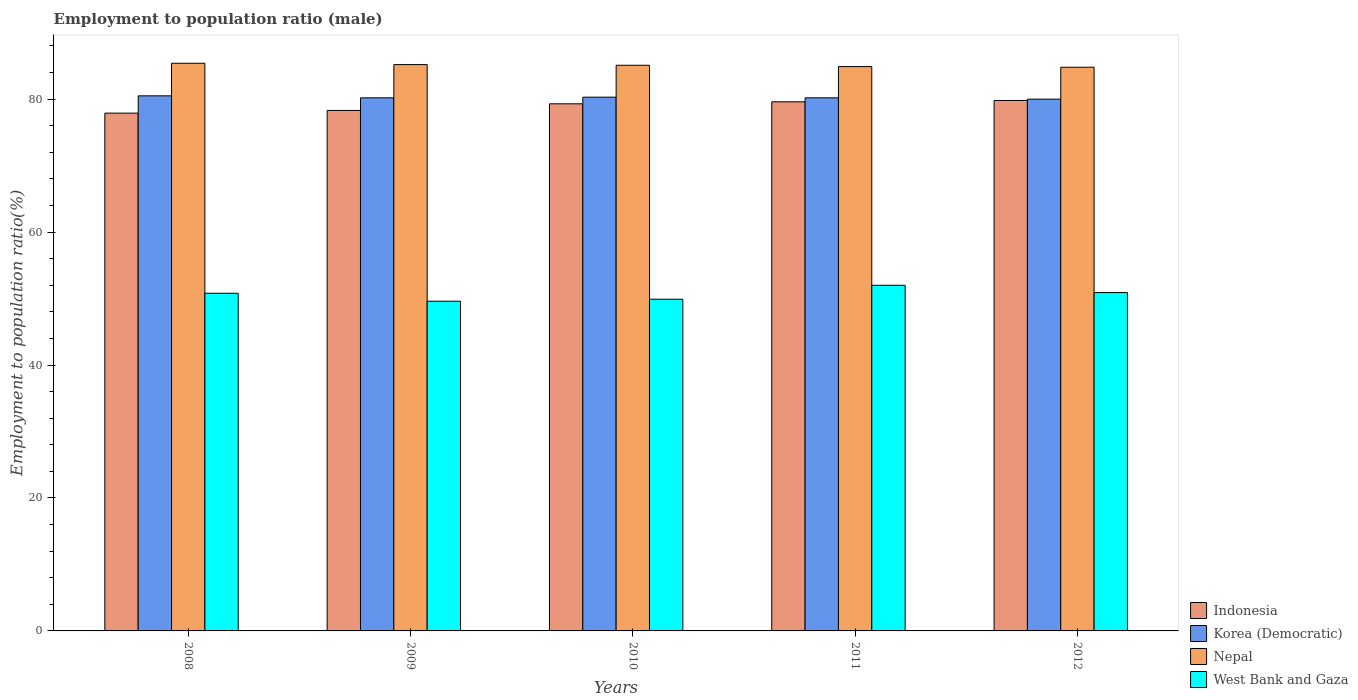How many different coloured bars are there?
Your response must be concise. 4. How many groups of bars are there?
Keep it short and to the point. 5. Are the number of bars per tick equal to the number of legend labels?
Your answer should be very brief. Yes. What is the employment to population ratio in West Bank and Gaza in 2011?
Your answer should be compact. 52. Across all years, what is the maximum employment to population ratio in Korea (Democratic)?
Offer a terse response. 80.5. Across all years, what is the minimum employment to population ratio in Nepal?
Offer a very short reply. 84.8. What is the total employment to population ratio in Korea (Democratic) in the graph?
Offer a terse response. 401.2. What is the difference between the employment to population ratio in Korea (Democratic) in 2009 and that in 2012?
Provide a succinct answer. 0.2. What is the difference between the employment to population ratio in Nepal in 2009 and the employment to population ratio in West Bank and Gaza in 2012?
Provide a short and direct response. 34.3. What is the average employment to population ratio in Korea (Democratic) per year?
Ensure brevity in your answer.  80.24. In the year 2012, what is the difference between the employment to population ratio in Indonesia and employment to population ratio in Korea (Democratic)?
Ensure brevity in your answer.  -0.2. In how many years, is the employment to population ratio in Indonesia greater than 60 %?
Give a very brief answer. 5. What is the ratio of the employment to population ratio in Nepal in 2008 to that in 2010?
Keep it short and to the point. 1. Is the employment to population ratio in Nepal in 2009 less than that in 2011?
Your answer should be compact. No. What is the difference between the highest and the second highest employment to population ratio in Nepal?
Offer a very short reply. 0.2. What is the difference between the highest and the lowest employment to population ratio in Indonesia?
Your response must be concise. 1.9. What does the 2nd bar from the left in 2008 represents?
Ensure brevity in your answer.  Korea (Democratic). What does the 4th bar from the right in 2011 represents?
Make the answer very short. Indonesia. Is it the case that in every year, the sum of the employment to population ratio in Nepal and employment to population ratio in Korea (Democratic) is greater than the employment to population ratio in West Bank and Gaza?
Keep it short and to the point. Yes. What is the difference between two consecutive major ticks on the Y-axis?
Your response must be concise. 20. Does the graph contain any zero values?
Ensure brevity in your answer.  No. Does the graph contain grids?
Your response must be concise. No. Where does the legend appear in the graph?
Ensure brevity in your answer.  Bottom right. How are the legend labels stacked?
Your response must be concise. Vertical. What is the title of the graph?
Your answer should be very brief. Employment to population ratio (male). What is the label or title of the X-axis?
Give a very brief answer. Years. What is the label or title of the Y-axis?
Keep it short and to the point. Employment to population ratio(%). What is the Employment to population ratio(%) of Indonesia in 2008?
Ensure brevity in your answer.  77.9. What is the Employment to population ratio(%) of Korea (Democratic) in 2008?
Offer a terse response. 80.5. What is the Employment to population ratio(%) in Nepal in 2008?
Offer a terse response. 85.4. What is the Employment to population ratio(%) of West Bank and Gaza in 2008?
Provide a short and direct response. 50.8. What is the Employment to population ratio(%) of Indonesia in 2009?
Keep it short and to the point. 78.3. What is the Employment to population ratio(%) of Korea (Democratic) in 2009?
Provide a short and direct response. 80.2. What is the Employment to population ratio(%) in Nepal in 2009?
Make the answer very short. 85.2. What is the Employment to population ratio(%) in West Bank and Gaza in 2009?
Your response must be concise. 49.6. What is the Employment to population ratio(%) of Indonesia in 2010?
Your response must be concise. 79.3. What is the Employment to population ratio(%) of Korea (Democratic) in 2010?
Give a very brief answer. 80.3. What is the Employment to population ratio(%) of Nepal in 2010?
Make the answer very short. 85.1. What is the Employment to population ratio(%) of West Bank and Gaza in 2010?
Your response must be concise. 49.9. What is the Employment to population ratio(%) in Indonesia in 2011?
Make the answer very short. 79.6. What is the Employment to population ratio(%) of Korea (Democratic) in 2011?
Offer a terse response. 80.2. What is the Employment to population ratio(%) of Nepal in 2011?
Provide a short and direct response. 84.9. What is the Employment to population ratio(%) in West Bank and Gaza in 2011?
Make the answer very short. 52. What is the Employment to population ratio(%) of Indonesia in 2012?
Ensure brevity in your answer.  79.8. What is the Employment to population ratio(%) in Korea (Democratic) in 2012?
Provide a short and direct response. 80. What is the Employment to population ratio(%) in Nepal in 2012?
Offer a very short reply. 84.8. What is the Employment to population ratio(%) in West Bank and Gaza in 2012?
Ensure brevity in your answer.  50.9. Across all years, what is the maximum Employment to population ratio(%) in Indonesia?
Provide a short and direct response. 79.8. Across all years, what is the maximum Employment to population ratio(%) of Korea (Democratic)?
Ensure brevity in your answer.  80.5. Across all years, what is the maximum Employment to population ratio(%) in Nepal?
Provide a short and direct response. 85.4. Across all years, what is the maximum Employment to population ratio(%) of West Bank and Gaza?
Your response must be concise. 52. Across all years, what is the minimum Employment to population ratio(%) in Indonesia?
Your answer should be compact. 77.9. Across all years, what is the minimum Employment to population ratio(%) of Korea (Democratic)?
Your answer should be compact. 80. Across all years, what is the minimum Employment to population ratio(%) in Nepal?
Make the answer very short. 84.8. Across all years, what is the minimum Employment to population ratio(%) of West Bank and Gaza?
Keep it short and to the point. 49.6. What is the total Employment to population ratio(%) in Indonesia in the graph?
Provide a succinct answer. 394.9. What is the total Employment to population ratio(%) of Korea (Democratic) in the graph?
Your answer should be compact. 401.2. What is the total Employment to population ratio(%) of Nepal in the graph?
Your answer should be very brief. 425.4. What is the total Employment to population ratio(%) in West Bank and Gaza in the graph?
Ensure brevity in your answer.  253.2. What is the difference between the Employment to population ratio(%) in Indonesia in 2008 and that in 2009?
Make the answer very short. -0.4. What is the difference between the Employment to population ratio(%) of Korea (Democratic) in 2008 and that in 2009?
Your answer should be very brief. 0.3. What is the difference between the Employment to population ratio(%) of West Bank and Gaza in 2008 and that in 2009?
Ensure brevity in your answer.  1.2. What is the difference between the Employment to population ratio(%) of Indonesia in 2008 and that in 2010?
Your response must be concise. -1.4. What is the difference between the Employment to population ratio(%) in Korea (Democratic) in 2008 and that in 2010?
Offer a very short reply. 0.2. What is the difference between the Employment to population ratio(%) in Nepal in 2008 and that in 2010?
Your response must be concise. 0.3. What is the difference between the Employment to population ratio(%) in West Bank and Gaza in 2008 and that in 2010?
Give a very brief answer. 0.9. What is the difference between the Employment to population ratio(%) of Indonesia in 2008 and that in 2011?
Offer a very short reply. -1.7. What is the difference between the Employment to population ratio(%) of West Bank and Gaza in 2008 and that in 2012?
Make the answer very short. -0.1. What is the difference between the Employment to population ratio(%) in Indonesia in 2009 and that in 2010?
Provide a succinct answer. -1. What is the difference between the Employment to population ratio(%) in Korea (Democratic) in 2009 and that in 2010?
Offer a terse response. -0.1. What is the difference between the Employment to population ratio(%) of Nepal in 2009 and that in 2010?
Provide a short and direct response. 0.1. What is the difference between the Employment to population ratio(%) of West Bank and Gaza in 2009 and that in 2010?
Your answer should be compact. -0.3. What is the difference between the Employment to population ratio(%) of Korea (Democratic) in 2009 and that in 2011?
Provide a succinct answer. 0. What is the difference between the Employment to population ratio(%) of Indonesia in 2009 and that in 2012?
Ensure brevity in your answer.  -1.5. What is the difference between the Employment to population ratio(%) in Korea (Democratic) in 2010 and that in 2011?
Your answer should be very brief. 0.1. What is the difference between the Employment to population ratio(%) of Nepal in 2010 and that in 2011?
Ensure brevity in your answer.  0.2. What is the difference between the Employment to population ratio(%) in Indonesia in 2010 and that in 2012?
Your answer should be very brief. -0.5. What is the difference between the Employment to population ratio(%) in Korea (Democratic) in 2010 and that in 2012?
Offer a terse response. 0.3. What is the difference between the Employment to population ratio(%) of Indonesia in 2011 and that in 2012?
Ensure brevity in your answer.  -0.2. What is the difference between the Employment to population ratio(%) of West Bank and Gaza in 2011 and that in 2012?
Make the answer very short. 1.1. What is the difference between the Employment to population ratio(%) in Indonesia in 2008 and the Employment to population ratio(%) in Korea (Democratic) in 2009?
Your response must be concise. -2.3. What is the difference between the Employment to population ratio(%) in Indonesia in 2008 and the Employment to population ratio(%) in West Bank and Gaza in 2009?
Make the answer very short. 28.3. What is the difference between the Employment to population ratio(%) in Korea (Democratic) in 2008 and the Employment to population ratio(%) in Nepal in 2009?
Offer a very short reply. -4.7. What is the difference between the Employment to population ratio(%) of Korea (Democratic) in 2008 and the Employment to population ratio(%) of West Bank and Gaza in 2009?
Your response must be concise. 30.9. What is the difference between the Employment to population ratio(%) of Nepal in 2008 and the Employment to population ratio(%) of West Bank and Gaza in 2009?
Provide a short and direct response. 35.8. What is the difference between the Employment to population ratio(%) of Indonesia in 2008 and the Employment to population ratio(%) of West Bank and Gaza in 2010?
Your answer should be compact. 28. What is the difference between the Employment to population ratio(%) of Korea (Democratic) in 2008 and the Employment to population ratio(%) of West Bank and Gaza in 2010?
Give a very brief answer. 30.6. What is the difference between the Employment to population ratio(%) of Nepal in 2008 and the Employment to population ratio(%) of West Bank and Gaza in 2010?
Give a very brief answer. 35.5. What is the difference between the Employment to population ratio(%) of Indonesia in 2008 and the Employment to population ratio(%) of Korea (Democratic) in 2011?
Ensure brevity in your answer.  -2.3. What is the difference between the Employment to population ratio(%) in Indonesia in 2008 and the Employment to population ratio(%) in West Bank and Gaza in 2011?
Give a very brief answer. 25.9. What is the difference between the Employment to population ratio(%) in Korea (Democratic) in 2008 and the Employment to population ratio(%) in Nepal in 2011?
Provide a short and direct response. -4.4. What is the difference between the Employment to population ratio(%) in Nepal in 2008 and the Employment to population ratio(%) in West Bank and Gaza in 2011?
Your response must be concise. 33.4. What is the difference between the Employment to population ratio(%) in Indonesia in 2008 and the Employment to population ratio(%) in Nepal in 2012?
Provide a short and direct response. -6.9. What is the difference between the Employment to population ratio(%) of Korea (Democratic) in 2008 and the Employment to population ratio(%) of West Bank and Gaza in 2012?
Provide a succinct answer. 29.6. What is the difference between the Employment to population ratio(%) in Nepal in 2008 and the Employment to population ratio(%) in West Bank and Gaza in 2012?
Your answer should be compact. 34.5. What is the difference between the Employment to population ratio(%) of Indonesia in 2009 and the Employment to population ratio(%) of West Bank and Gaza in 2010?
Make the answer very short. 28.4. What is the difference between the Employment to population ratio(%) in Korea (Democratic) in 2009 and the Employment to population ratio(%) in West Bank and Gaza in 2010?
Your answer should be very brief. 30.3. What is the difference between the Employment to population ratio(%) of Nepal in 2009 and the Employment to population ratio(%) of West Bank and Gaza in 2010?
Make the answer very short. 35.3. What is the difference between the Employment to population ratio(%) in Indonesia in 2009 and the Employment to population ratio(%) in Nepal in 2011?
Give a very brief answer. -6.6. What is the difference between the Employment to population ratio(%) of Indonesia in 2009 and the Employment to population ratio(%) of West Bank and Gaza in 2011?
Your response must be concise. 26.3. What is the difference between the Employment to population ratio(%) in Korea (Democratic) in 2009 and the Employment to population ratio(%) in Nepal in 2011?
Keep it short and to the point. -4.7. What is the difference between the Employment to population ratio(%) in Korea (Democratic) in 2009 and the Employment to population ratio(%) in West Bank and Gaza in 2011?
Keep it short and to the point. 28.2. What is the difference between the Employment to population ratio(%) of Nepal in 2009 and the Employment to population ratio(%) of West Bank and Gaza in 2011?
Your response must be concise. 33.2. What is the difference between the Employment to population ratio(%) in Indonesia in 2009 and the Employment to population ratio(%) in Nepal in 2012?
Offer a very short reply. -6.5. What is the difference between the Employment to population ratio(%) of Indonesia in 2009 and the Employment to population ratio(%) of West Bank and Gaza in 2012?
Provide a succinct answer. 27.4. What is the difference between the Employment to population ratio(%) of Korea (Democratic) in 2009 and the Employment to population ratio(%) of West Bank and Gaza in 2012?
Provide a short and direct response. 29.3. What is the difference between the Employment to population ratio(%) of Nepal in 2009 and the Employment to population ratio(%) of West Bank and Gaza in 2012?
Provide a succinct answer. 34.3. What is the difference between the Employment to population ratio(%) of Indonesia in 2010 and the Employment to population ratio(%) of Korea (Democratic) in 2011?
Your answer should be compact. -0.9. What is the difference between the Employment to population ratio(%) in Indonesia in 2010 and the Employment to population ratio(%) in Nepal in 2011?
Make the answer very short. -5.6. What is the difference between the Employment to population ratio(%) in Indonesia in 2010 and the Employment to population ratio(%) in West Bank and Gaza in 2011?
Your response must be concise. 27.3. What is the difference between the Employment to population ratio(%) of Korea (Democratic) in 2010 and the Employment to population ratio(%) of Nepal in 2011?
Offer a very short reply. -4.6. What is the difference between the Employment to population ratio(%) in Korea (Democratic) in 2010 and the Employment to population ratio(%) in West Bank and Gaza in 2011?
Keep it short and to the point. 28.3. What is the difference between the Employment to population ratio(%) in Nepal in 2010 and the Employment to population ratio(%) in West Bank and Gaza in 2011?
Your answer should be very brief. 33.1. What is the difference between the Employment to population ratio(%) in Indonesia in 2010 and the Employment to population ratio(%) in West Bank and Gaza in 2012?
Provide a short and direct response. 28.4. What is the difference between the Employment to population ratio(%) of Korea (Democratic) in 2010 and the Employment to population ratio(%) of Nepal in 2012?
Offer a terse response. -4.5. What is the difference between the Employment to population ratio(%) of Korea (Democratic) in 2010 and the Employment to population ratio(%) of West Bank and Gaza in 2012?
Your answer should be compact. 29.4. What is the difference between the Employment to population ratio(%) of Nepal in 2010 and the Employment to population ratio(%) of West Bank and Gaza in 2012?
Your answer should be very brief. 34.2. What is the difference between the Employment to population ratio(%) of Indonesia in 2011 and the Employment to population ratio(%) of Korea (Democratic) in 2012?
Keep it short and to the point. -0.4. What is the difference between the Employment to population ratio(%) in Indonesia in 2011 and the Employment to population ratio(%) in Nepal in 2012?
Keep it short and to the point. -5.2. What is the difference between the Employment to population ratio(%) in Indonesia in 2011 and the Employment to population ratio(%) in West Bank and Gaza in 2012?
Keep it short and to the point. 28.7. What is the difference between the Employment to population ratio(%) of Korea (Democratic) in 2011 and the Employment to population ratio(%) of West Bank and Gaza in 2012?
Your response must be concise. 29.3. What is the average Employment to population ratio(%) in Indonesia per year?
Ensure brevity in your answer.  78.98. What is the average Employment to population ratio(%) of Korea (Democratic) per year?
Give a very brief answer. 80.24. What is the average Employment to population ratio(%) of Nepal per year?
Offer a terse response. 85.08. What is the average Employment to population ratio(%) in West Bank and Gaza per year?
Offer a very short reply. 50.64. In the year 2008, what is the difference between the Employment to population ratio(%) in Indonesia and Employment to population ratio(%) in Korea (Democratic)?
Provide a succinct answer. -2.6. In the year 2008, what is the difference between the Employment to population ratio(%) of Indonesia and Employment to population ratio(%) of West Bank and Gaza?
Keep it short and to the point. 27.1. In the year 2008, what is the difference between the Employment to population ratio(%) of Korea (Democratic) and Employment to population ratio(%) of West Bank and Gaza?
Keep it short and to the point. 29.7. In the year 2008, what is the difference between the Employment to population ratio(%) in Nepal and Employment to population ratio(%) in West Bank and Gaza?
Keep it short and to the point. 34.6. In the year 2009, what is the difference between the Employment to population ratio(%) of Indonesia and Employment to population ratio(%) of Korea (Democratic)?
Make the answer very short. -1.9. In the year 2009, what is the difference between the Employment to population ratio(%) in Indonesia and Employment to population ratio(%) in Nepal?
Give a very brief answer. -6.9. In the year 2009, what is the difference between the Employment to population ratio(%) of Indonesia and Employment to population ratio(%) of West Bank and Gaza?
Provide a succinct answer. 28.7. In the year 2009, what is the difference between the Employment to population ratio(%) in Korea (Democratic) and Employment to population ratio(%) in Nepal?
Your answer should be compact. -5. In the year 2009, what is the difference between the Employment to population ratio(%) in Korea (Democratic) and Employment to population ratio(%) in West Bank and Gaza?
Provide a short and direct response. 30.6. In the year 2009, what is the difference between the Employment to population ratio(%) in Nepal and Employment to population ratio(%) in West Bank and Gaza?
Provide a short and direct response. 35.6. In the year 2010, what is the difference between the Employment to population ratio(%) in Indonesia and Employment to population ratio(%) in Korea (Democratic)?
Your answer should be very brief. -1. In the year 2010, what is the difference between the Employment to population ratio(%) of Indonesia and Employment to population ratio(%) of Nepal?
Your answer should be compact. -5.8. In the year 2010, what is the difference between the Employment to population ratio(%) of Indonesia and Employment to population ratio(%) of West Bank and Gaza?
Provide a succinct answer. 29.4. In the year 2010, what is the difference between the Employment to population ratio(%) in Korea (Democratic) and Employment to population ratio(%) in West Bank and Gaza?
Your answer should be compact. 30.4. In the year 2010, what is the difference between the Employment to population ratio(%) of Nepal and Employment to population ratio(%) of West Bank and Gaza?
Give a very brief answer. 35.2. In the year 2011, what is the difference between the Employment to population ratio(%) of Indonesia and Employment to population ratio(%) of Nepal?
Your answer should be very brief. -5.3. In the year 2011, what is the difference between the Employment to population ratio(%) of Indonesia and Employment to population ratio(%) of West Bank and Gaza?
Give a very brief answer. 27.6. In the year 2011, what is the difference between the Employment to population ratio(%) in Korea (Democratic) and Employment to population ratio(%) in West Bank and Gaza?
Keep it short and to the point. 28.2. In the year 2011, what is the difference between the Employment to population ratio(%) of Nepal and Employment to population ratio(%) of West Bank and Gaza?
Provide a short and direct response. 32.9. In the year 2012, what is the difference between the Employment to population ratio(%) of Indonesia and Employment to population ratio(%) of West Bank and Gaza?
Offer a very short reply. 28.9. In the year 2012, what is the difference between the Employment to population ratio(%) in Korea (Democratic) and Employment to population ratio(%) in West Bank and Gaza?
Your response must be concise. 29.1. In the year 2012, what is the difference between the Employment to population ratio(%) of Nepal and Employment to population ratio(%) of West Bank and Gaza?
Make the answer very short. 33.9. What is the ratio of the Employment to population ratio(%) of Nepal in 2008 to that in 2009?
Offer a terse response. 1. What is the ratio of the Employment to population ratio(%) of West Bank and Gaza in 2008 to that in 2009?
Your answer should be compact. 1.02. What is the ratio of the Employment to population ratio(%) of Indonesia in 2008 to that in 2010?
Ensure brevity in your answer.  0.98. What is the ratio of the Employment to population ratio(%) of Korea (Democratic) in 2008 to that in 2010?
Keep it short and to the point. 1. What is the ratio of the Employment to population ratio(%) in Indonesia in 2008 to that in 2011?
Offer a terse response. 0.98. What is the ratio of the Employment to population ratio(%) in Korea (Democratic) in 2008 to that in 2011?
Your answer should be compact. 1. What is the ratio of the Employment to population ratio(%) in Nepal in 2008 to that in 2011?
Give a very brief answer. 1.01. What is the ratio of the Employment to population ratio(%) of West Bank and Gaza in 2008 to that in 2011?
Provide a succinct answer. 0.98. What is the ratio of the Employment to population ratio(%) in Indonesia in 2008 to that in 2012?
Give a very brief answer. 0.98. What is the ratio of the Employment to population ratio(%) in Korea (Democratic) in 2008 to that in 2012?
Keep it short and to the point. 1.01. What is the ratio of the Employment to population ratio(%) in Nepal in 2008 to that in 2012?
Provide a short and direct response. 1.01. What is the ratio of the Employment to population ratio(%) of Indonesia in 2009 to that in 2010?
Your response must be concise. 0.99. What is the ratio of the Employment to population ratio(%) of Korea (Democratic) in 2009 to that in 2010?
Provide a short and direct response. 1. What is the ratio of the Employment to population ratio(%) in Indonesia in 2009 to that in 2011?
Your answer should be very brief. 0.98. What is the ratio of the Employment to population ratio(%) in Korea (Democratic) in 2009 to that in 2011?
Ensure brevity in your answer.  1. What is the ratio of the Employment to population ratio(%) of Nepal in 2009 to that in 2011?
Give a very brief answer. 1. What is the ratio of the Employment to population ratio(%) of West Bank and Gaza in 2009 to that in 2011?
Your response must be concise. 0.95. What is the ratio of the Employment to population ratio(%) of Indonesia in 2009 to that in 2012?
Your answer should be compact. 0.98. What is the ratio of the Employment to population ratio(%) of Nepal in 2009 to that in 2012?
Offer a terse response. 1. What is the ratio of the Employment to population ratio(%) of West Bank and Gaza in 2009 to that in 2012?
Ensure brevity in your answer.  0.97. What is the ratio of the Employment to population ratio(%) of Korea (Democratic) in 2010 to that in 2011?
Provide a short and direct response. 1. What is the ratio of the Employment to population ratio(%) in West Bank and Gaza in 2010 to that in 2011?
Keep it short and to the point. 0.96. What is the ratio of the Employment to population ratio(%) of Indonesia in 2010 to that in 2012?
Your answer should be compact. 0.99. What is the ratio of the Employment to population ratio(%) in Korea (Democratic) in 2010 to that in 2012?
Offer a very short reply. 1. What is the ratio of the Employment to population ratio(%) in Nepal in 2010 to that in 2012?
Your answer should be very brief. 1. What is the ratio of the Employment to population ratio(%) in West Bank and Gaza in 2010 to that in 2012?
Provide a succinct answer. 0.98. What is the ratio of the Employment to population ratio(%) of Korea (Democratic) in 2011 to that in 2012?
Offer a very short reply. 1. What is the ratio of the Employment to population ratio(%) of West Bank and Gaza in 2011 to that in 2012?
Make the answer very short. 1.02. What is the difference between the highest and the second highest Employment to population ratio(%) of Korea (Democratic)?
Your answer should be compact. 0.2. What is the difference between the highest and the lowest Employment to population ratio(%) in Korea (Democratic)?
Make the answer very short. 0.5. What is the difference between the highest and the lowest Employment to population ratio(%) in Nepal?
Provide a succinct answer. 0.6. 